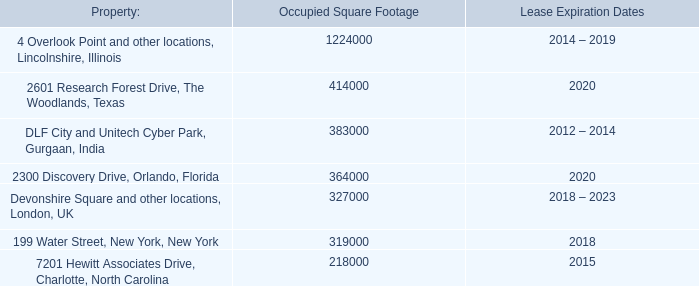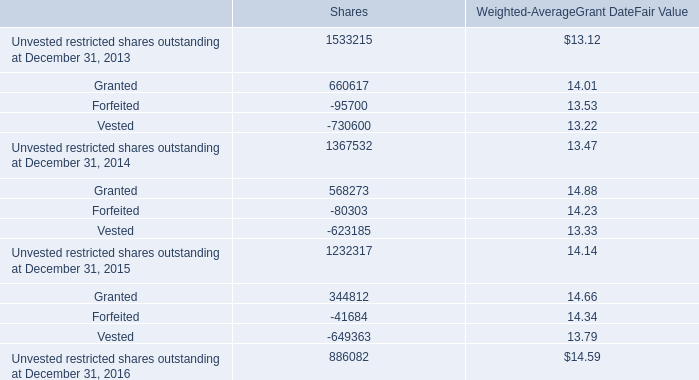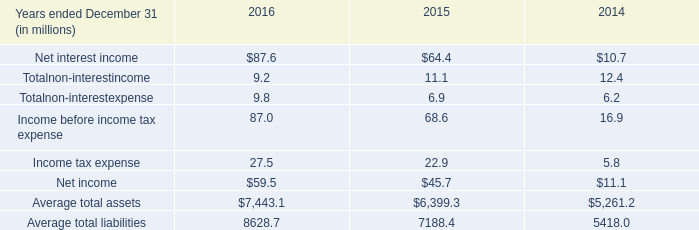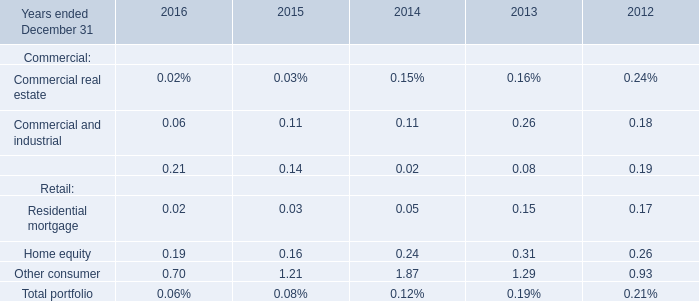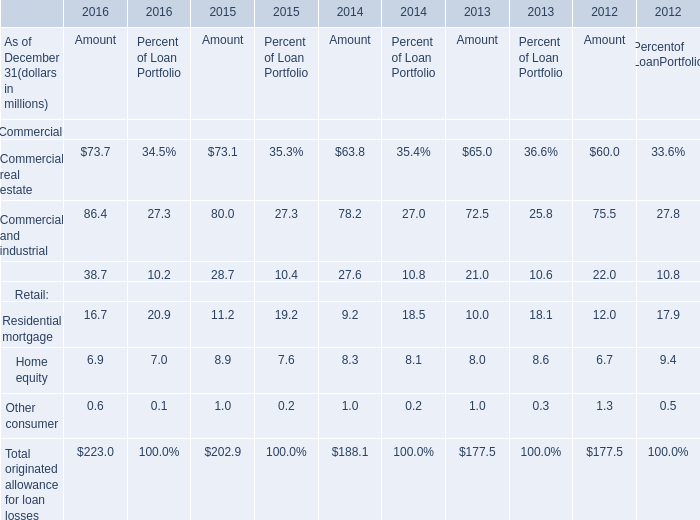How many Retail exceed the average of Retail in 2016? 
Answer: 1. 